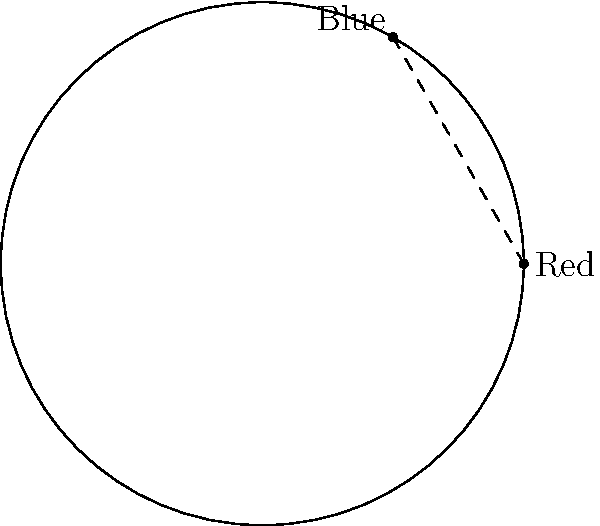On a color wheel with radius 5 units, the red pigment is located at (5,0) and the blue pigment is at (-2.5, 4.33). Calculate the distance between these two pigments using the distance formula. Round your answer to two decimal places. To find the distance between two points on a color wheel, we can use the distance formula:

$$d = \sqrt{(x_2-x_1)^2 + (y_2-y_1)^2}$$

Where $(x_1,y_1)$ is the coordinate of the first point (red pigment) and $(x_2,y_2)$ is the coordinate of the second point (blue pigment).

Given:
Red pigment: $(x_1,y_1) = (5,0)$
Blue pigment: $(x_2,y_2) = (-2.5, 4.33)$

Let's substitute these values into the formula:

$$d = \sqrt{(-2.5-5)^2 + (4.33-0)^2}$$

Simplify:
$$d = \sqrt{(-7.5)^2 + (4.33)^2}$$

Calculate the squares:
$$d = \sqrt{56.25 + 18.7489}$$

Add the values under the square root:
$$d = \sqrt{74.9989}$$

Take the square root:
$$d \approx 8.66$$

Rounding to two decimal places, we get 8.66 units.
Answer: 8.66 units 